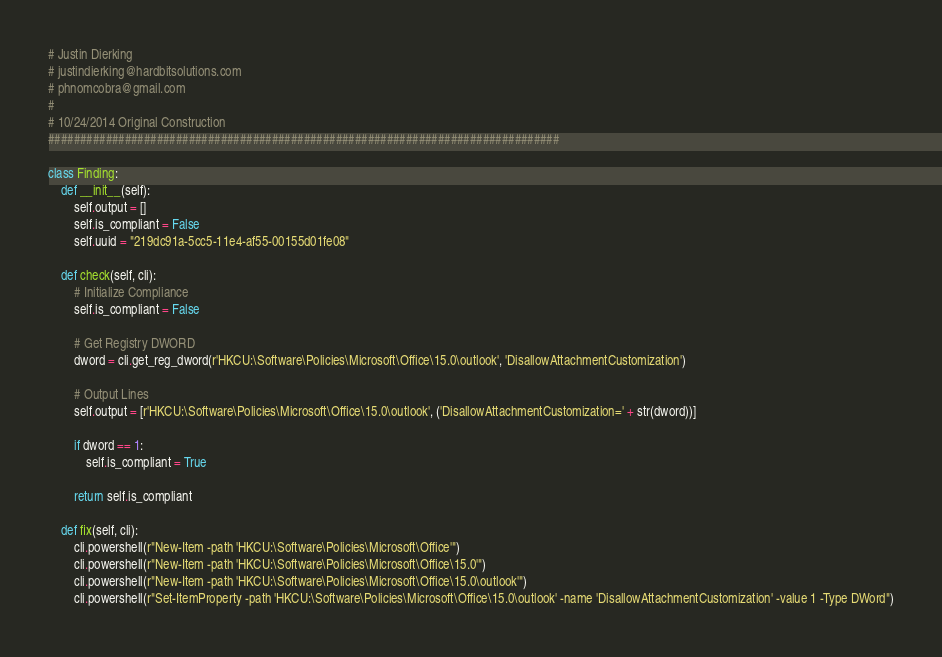Convert code to text. <code><loc_0><loc_0><loc_500><loc_500><_Python_># Justin Dierking
# justindierking@hardbitsolutions.com
# phnomcobra@gmail.com
#
# 10/24/2014 Original Construction
################################################################################

class Finding:
    def __init__(self):
        self.output = []
        self.is_compliant = False
        self.uuid = "219dc91a-5cc5-11e4-af55-00155d01fe08"
        
    def check(self, cli):
        # Initialize Compliance
        self.is_compliant = False

        # Get Registry DWORD
        dword = cli.get_reg_dword(r'HKCU:\Software\Policies\Microsoft\Office\15.0\outlook', 'DisallowAttachmentCustomization')

        # Output Lines
        self.output = [r'HKCU:\Software\Policies\Microsoft\Office\15.0\outlook', ('DisallowAttachmentCustomization=' + str(dword))]

        if dword == 1:
            self.is_compliant = True

        return self.is_compliant

    def fix(self, cli):
        cli.powershell(r"New-Item -path 'HKCU:\Software\Policies\Microsoft\Office'")
        cli.powershell(r"New-Item -path 'HKCU:\Software\Policies\Microsoft\Office\15.0'")
        cli.powershell(r"New-Item -path 'HKCU:\Software\Policies\Microsoft\Office\15.0\outlook'")
        cli.powershell(r"Set-ItemProperty -path 'HKCU:\Software\Policies\Microsoft\Office\15.0\outlook' -name 'DisallowAttachmentCustomization' -value 1 -Type DWord")
</code> 